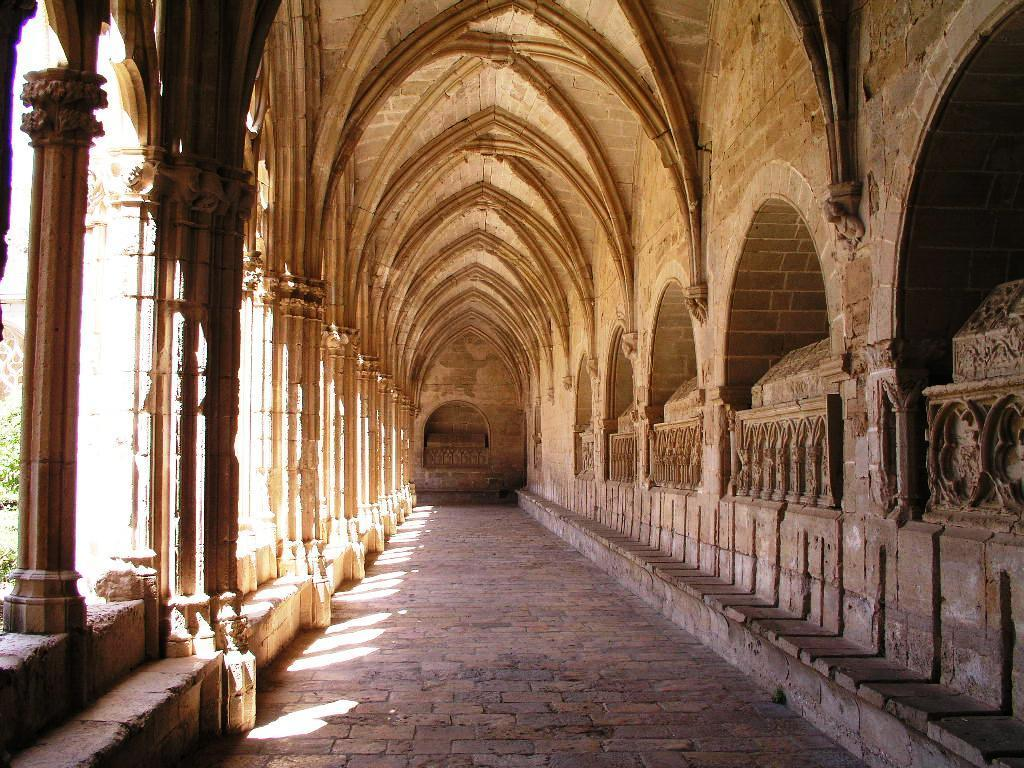What is the main subject of the image? The image shows the inner view of the Reial monestir de Santes Creus. What can be seen in the background of the image? There are trees visible in the image. Where is the goose sitting in the image? There is no goose present in the image. What type of nerve can be seen in the image? There are no nerves visible in the image; it shows the inner view of a monastery. 